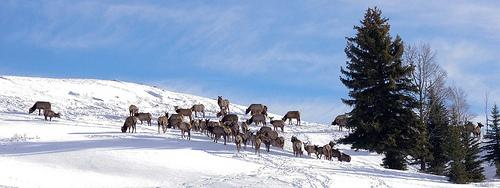Enumerate the notable objects and weather conditions present in the image. The image shows deer, evergreen and deciduous trees, hoof prints, snow on the ground, and a clear blue sky with some white clouds. Write a short description of what the wild animals are doing in the image. A group of wild deer are roaming and looking for food in the snow, with some being farther away from the main herd. Describe the image focusing on the animals and their surroundings. In the image, wild deer are seen grazing on a snowy hill among evergreen trees, deciduous trees, with a backdrop of a blue, clear sky. Express the key elements of the scene including the state of vegetation and main subjects. The scene features deer grazing in the snowy environment, with snow-covered trees as the only vegetation and a few clouds in the clear blue sky. Write a concise sentence describing the main scenery observed in the image. The image captures a snowy hill with a herd of deer, evergreen trees, and a blue sky with whispy clouds. Mention the dominant animal group and their activity in the picture. A group of deer are seen walking and grazing in the snow-covered ground, with a few animals away from the herd. Outline the major visual aspects of the image, focusing on fauna and their surroundings. The image highlights a group of deer on a snowy hill, with towering evergreen trees and a clear blue sky providing the backdrop. Provide a brief description of the primary subjects in the image. There's a herd of deer on a snowy hill, with some being away from the pack, foraging for food and leaving tracks in the snow. Give a concise description of the landscape and the animal life depicted in the picture. The picture portrays a wintry landscape with several deer roaming, grazing, and foraging for food on a snow-covered hill. Write a brief statement describing the actions of the wild animals in the image. The wild deer in the image are walking and grazing on a snowy hill, with some animals away from the herd and surrounded by trees. 